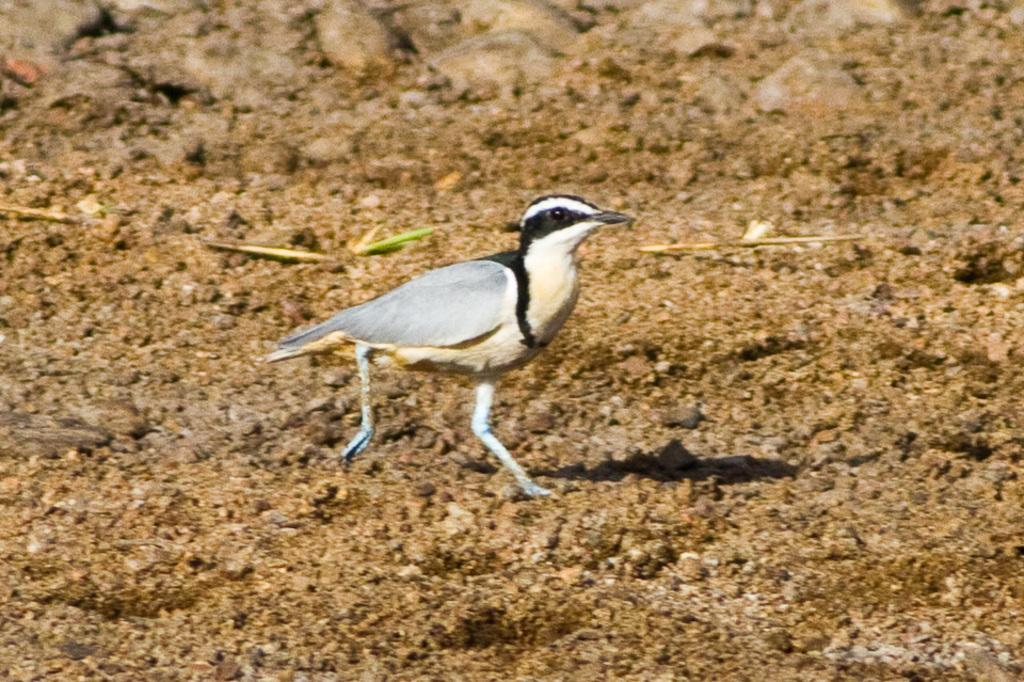What is the main subject in the center of the image? There is a bird in the center of the image. What type of terrain is visible at the bottom of the image? There is sand and small stones at the bottom of the image. Can you see a pickle in the image? No, there is no pickle present in the image. Is there a giraffe in the image? No, there is no giraffe present in the image. 